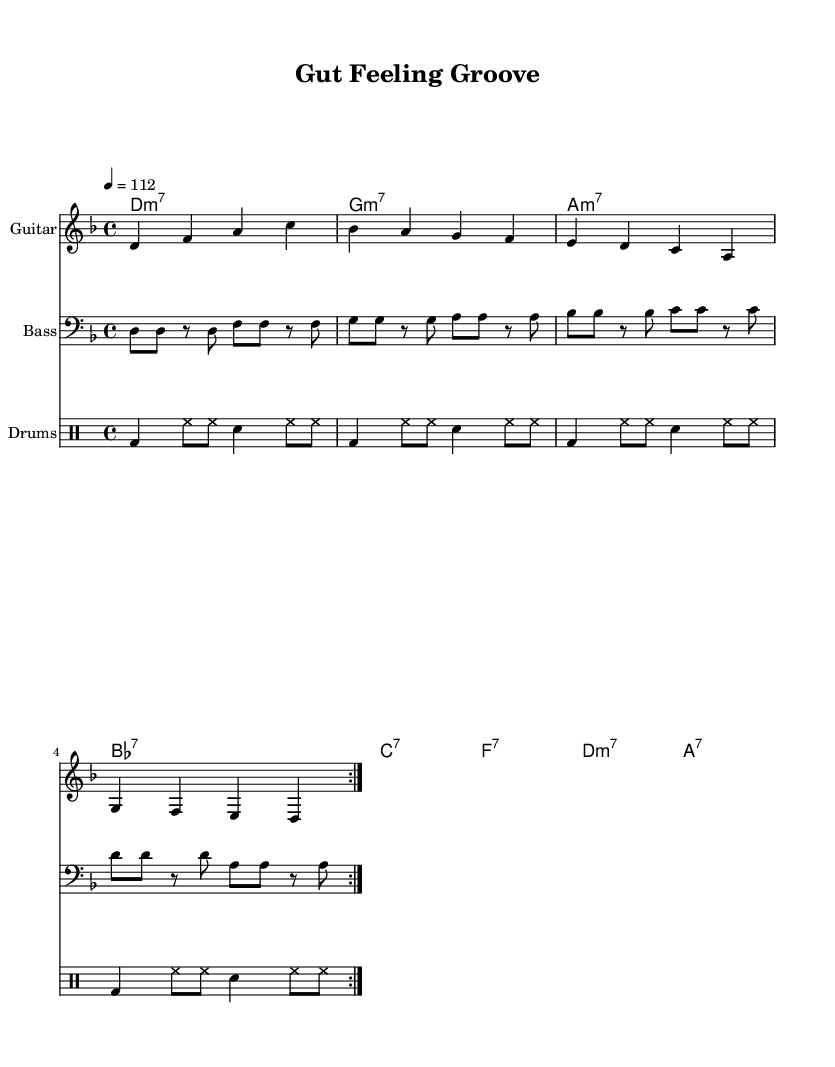What is the key signature of this music? The key signature is D minor, which has one flat (B flat). This can be determined by looking at the key signature symbol at the beginning of the staff, which corresponds to the D minor scale.
Answer: D minor What is the time signature of this music? The time signature is 4/4, indicating there are four beats in each measure and the quarter note gets one beat. This is shown at the beginning of the score, represented by the numbers stacked on top of each other.
Answer: 4/4 What is the tempo marking for this piece? The tempo marking is 112 beats per minute, indicated at the beginning of the score with "4 = 112". This tempo gives a moderate pace to the music.
Answer: 112 How many measures are repeated in this piece? There are two measures being repeated throughout the score, as denoted by the "volta 2" marking in the melody, bass, and drums sections. This indicates that the preceding section is to be played twice before moving on.
Answer: 2 What instrument plays the melody? The instrument playing the melody is the guitar, which is labeled at the beginning of its staff. This distinguishes the guitar part from the bass and the drums in the score.
Answer: Guitar What harmonic function does the chord "D minor 7" serve in this piece? The chord "D minor 7" is the tonic chord in the context of D minor key, providing a sense of home base for the piece. Its placement at the beginning of the chord progression establishes the tonal center of the music.
Answer: Tonic What are the primary genres represented in this piece? The primary genres represented in this piece are funk and rock, evidenced by the groove-based rhythms in the bass and drum patterns, as well as the melodic style typically characteristic of funk-rock fusion music.
Answer: Funk-rock 